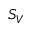<formula> <loc_0><loc_0><loc_500><loc_500>S _ { V }</formula> 